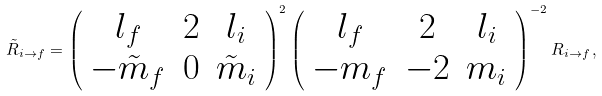Convert formula to latex. <formula><loc_0><loc_0><loc_500><loc_500>\tilde { R } _ { i \rightarrow f } = \left ( \begin{array} { c c c } l _ { f } & 2 & l _ { i } \\ - \tilde { m } _ { f } & 0 & \tilde { m } _ { i } \end{array} \right ) ^ { 2 } \left ( \begin{array} { c c c } l _ { f } & 2 & l _ { i } \\ - m _ { f } & - 2 & m _ { i } \end{array} \right ) ^ { - 2 } R _ { i \rightarrow f } \, ,</formula> 